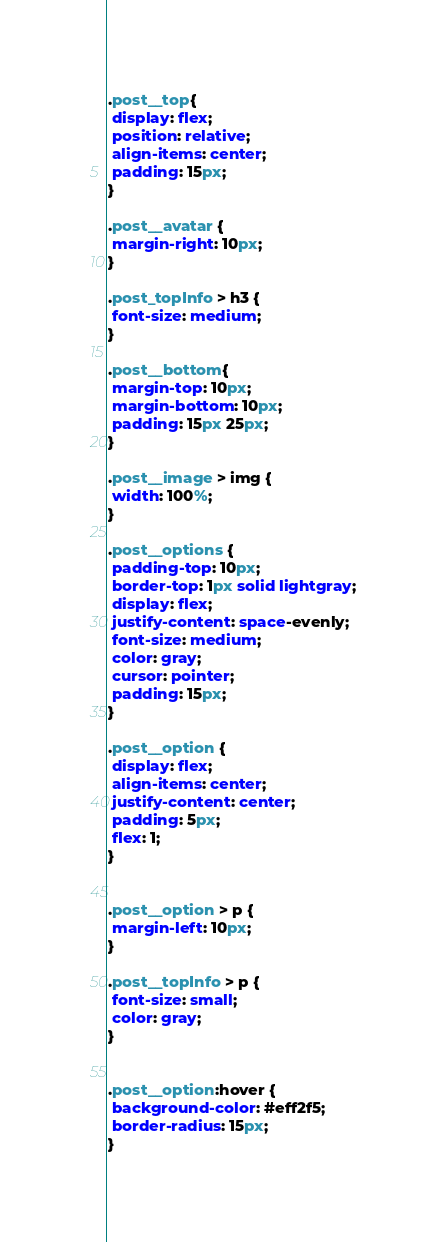Convert code to text. <code><loc_0><loc_0><loc_500><loc_500><_CSS_>.post__top{
 display: flex;
 position: relative;
 align-items: center;
 padding: 15px;
}

.post__avatar {
 margin-right: 10px;
}

.post_topInfo > h3 {
 font-size: medium;
}

.post__bottom{
 margin-top: 10px;
 margin-bottom: 10px;
 padding: 15px 25px;
}

.post__image > img {
 width: 100%;
}

.post__options {
 padding-top: 10px;
 border-top: 1px solid lightgray;
 display: flex;
 justify-content: space-evenly;
 font-size: medium;
 color: gray;
 cursor: pointer;
 padding: 15px;
}

.post__option {
 display: flex;
 align-items: center;
 justify-content: center;
 padding: 5px;
 flex: 1;
}


.post__option > p {
 margin-left: 10px;
}

.post__topInfo > p {
 font-size: small;
 color: gray;
}


.post__option:hover {
 background-color: #eff2f5;
 border-radius: 15px;
}</code> 